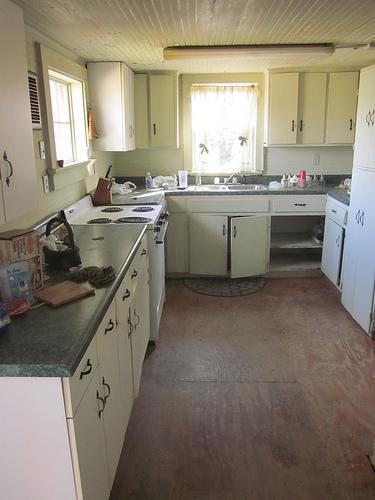How many knives are on the block?
Give a very brief answer. 1. 